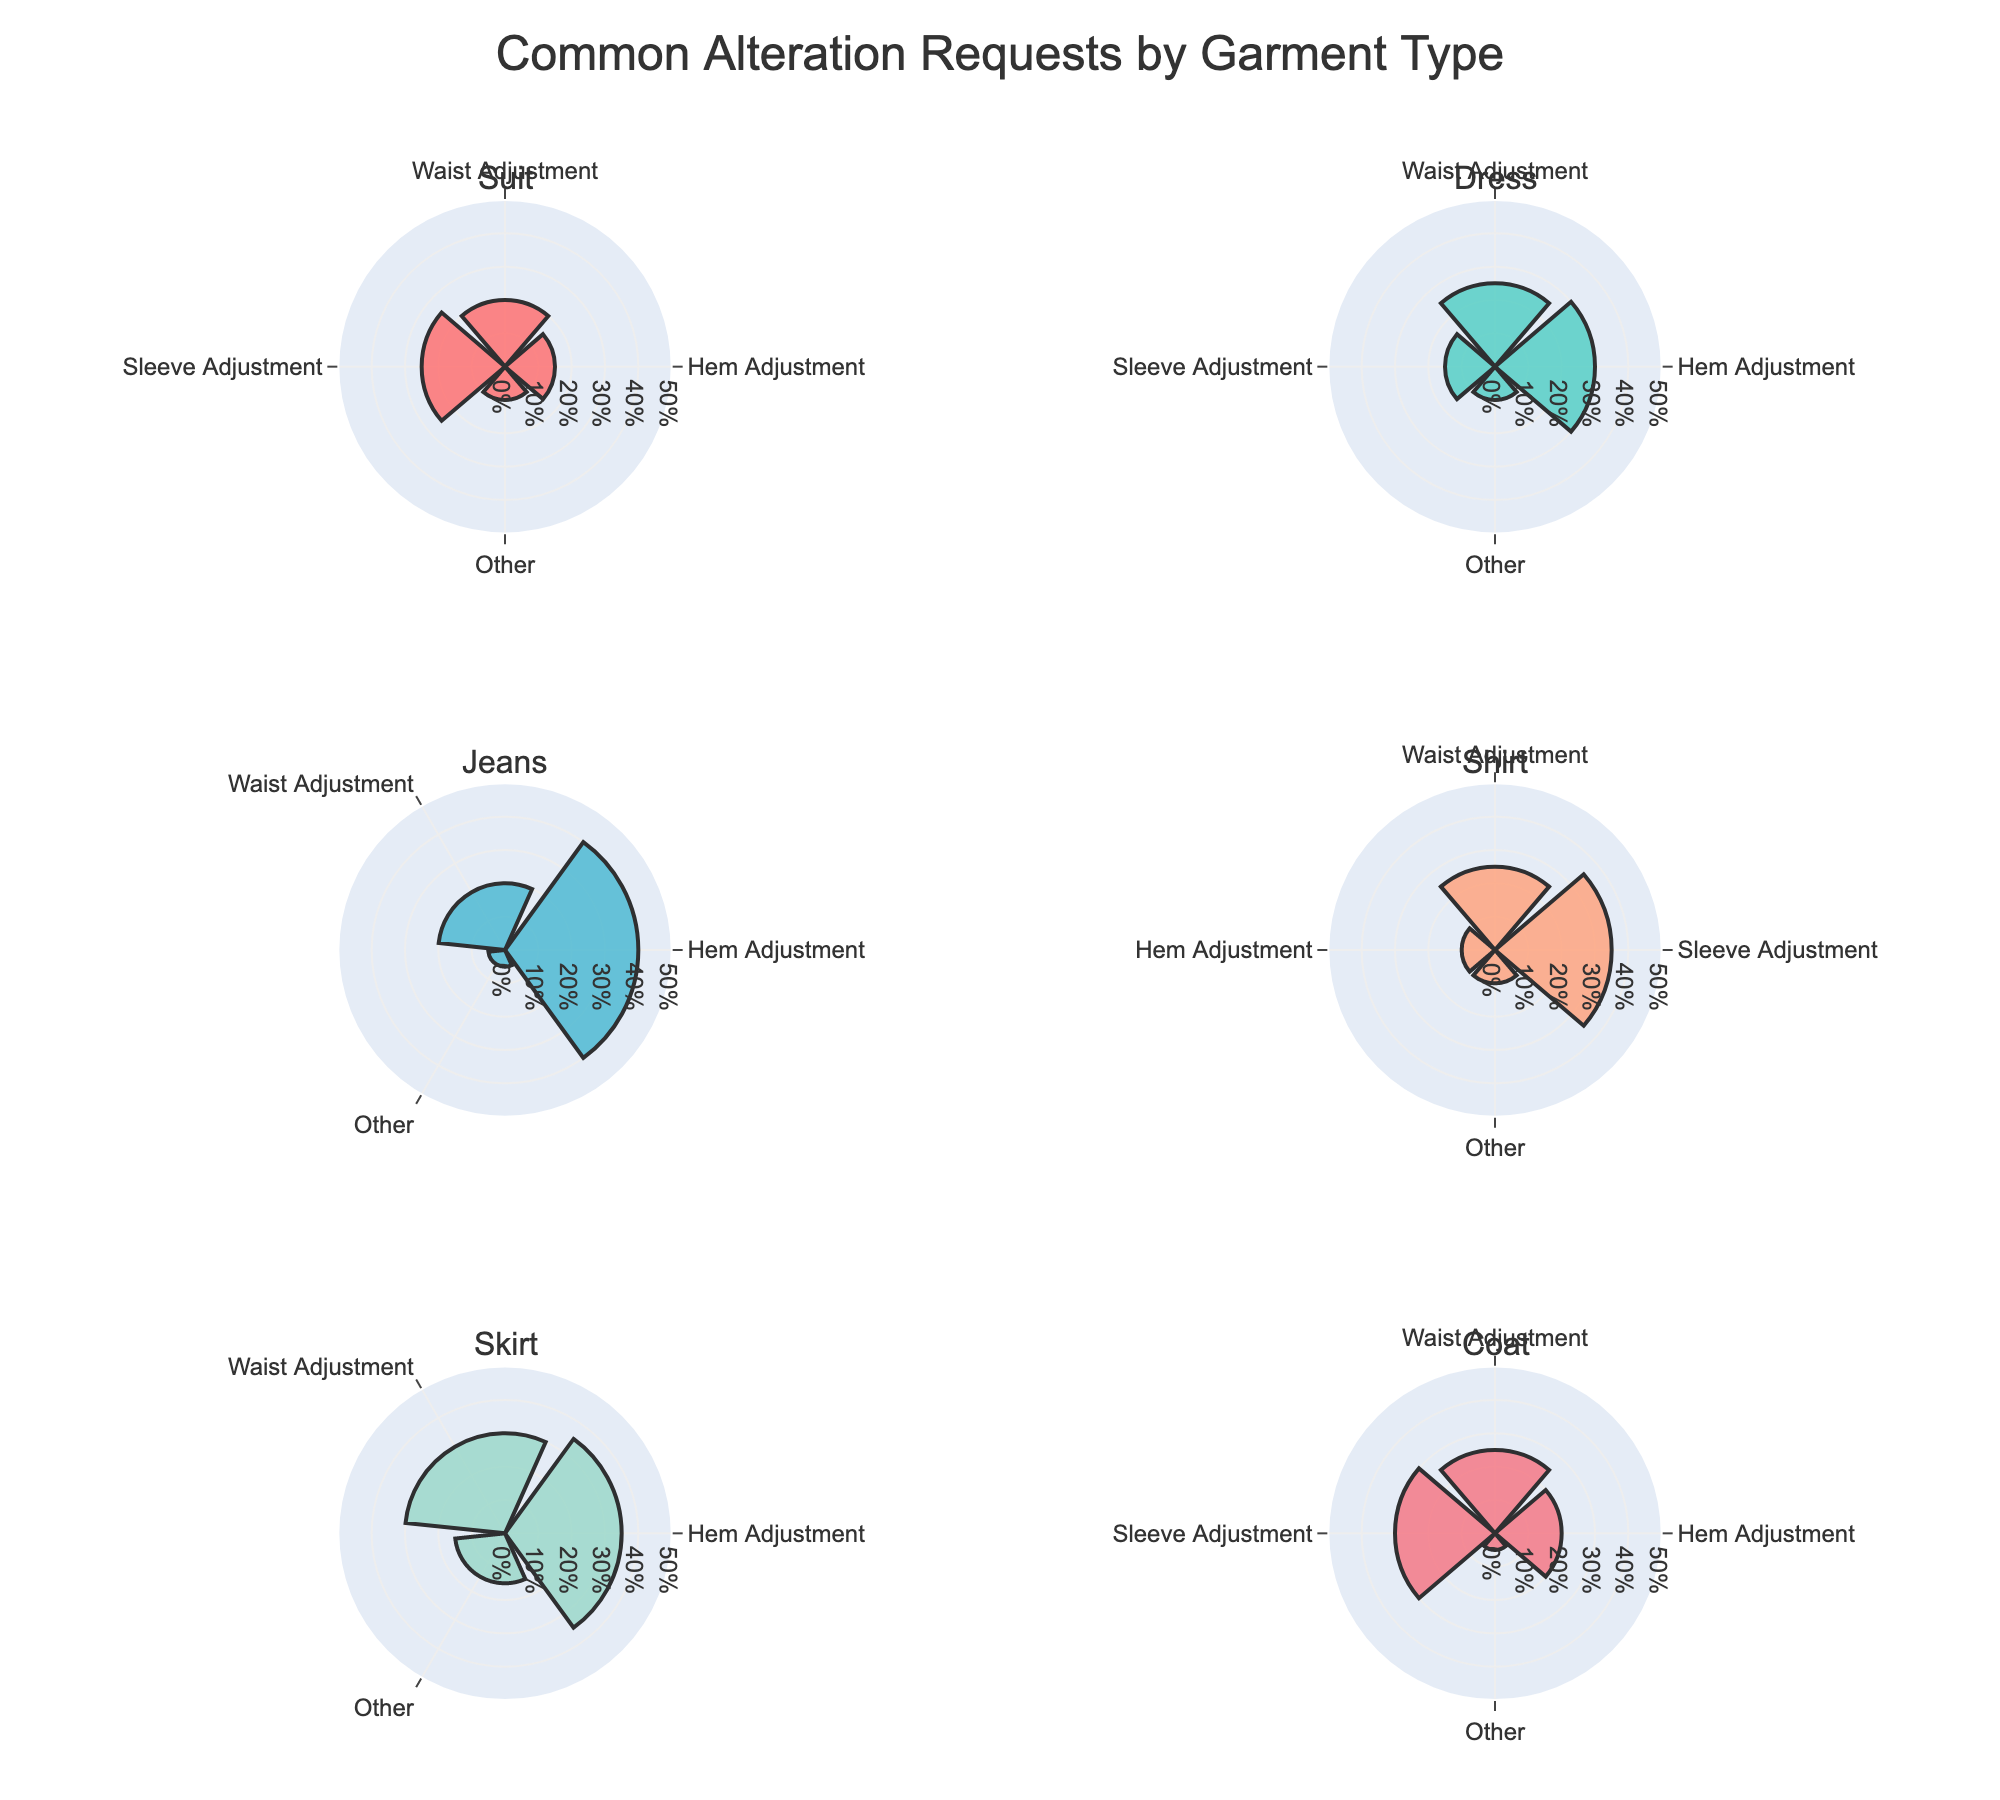What is the title of the figure? The title of the figure is usually located at the top and it summarizes the content of the visualization.
Answer: Common Alteration Requests by Garment Type Which garment type requires the most sleeve adjustments? We need to look for the highest percentage in the sleeve adjustment category across all subplots.
Answer: Shirt How many garment types include "Other" as an alteration type? Count the number of subplots where "Other" appears.
Answer: 6 Which garment type has the highest percentage for hem adjustments? We look for the highest value under the "Hem Adjustment" section across all the garments.
Answer: Jeans What is the total percentage of waist adjustments for Suit and Dress? Add the waist adjustment percentages of Suit and Dress. (20% + 25%)
Answer: 45% Which alteration type is the least common for Jeans? Identify the smallest percentage value among all alteration types for Jeans.
Answer: Other How does the hem adjustment percentage for Coat compare to Dress? Compare the hem adjustment values of Coat and Dress. Coat = 20%, Dress = 30%, thus Coat < Dress
Answer: Lower Is sleeve adjustment more or less common for Coat compared to Suit? Compare the sleeve adjustment values of Coat and Suit. Coat = 30%, Suit = 25%, thus Coat > Suit
Answer: More Which garment type has the highest variation in alteration requests? Calculate the range (max - min) for each garment type and identify the highest one.
Answer: Jeans (Range: 40% - 5% = 35%) Among Skirt and Coat, which garment type has the higher waist adjustment percentage? Compare the waist adjustment values for Skirt and Coat. Skirt = 30%, Coat = 25%
Answer: Skirt 